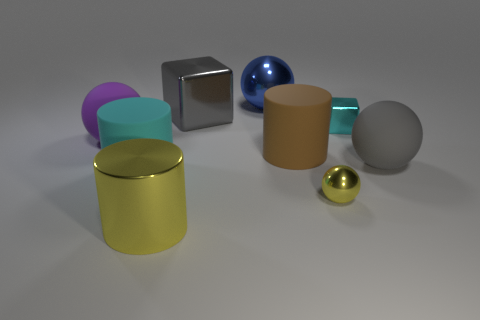Add 1 small cyan things. How many objects exist? 10 Add 7 large blue shiny things. How many large blue shiny things exist? 8 Subtract 0 red blocks. How many objects are left? 9 Subtract all blocks. How many objects are left? 7 Subtract all large red shiny cubes. Subtract all brown matte objects. How many objects are left? 8 Add 8 yellow balls. How many yellow balls are left? 9 